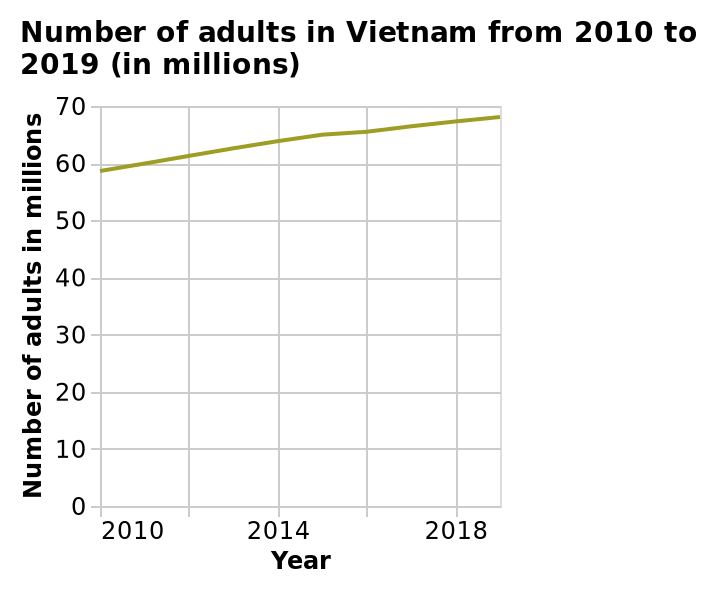<image>
What was the approximate number of Vietnamese adults in 2010?  Just under 60 million adults. What is the range of the y-axis in the line plot?  The range of the y-axis in the line plot is from 0 to 70, labeled Number of adults in millions. Describe the following image in detail Number of adults in Vietnam from 2010 to 2019 (in millions) is a line plot. Year is drawn using a linear scale from 2010 to 2018 along the x-axis. There is a linear scale from 0 to 70 on the y-axis, labeled Number of adults in millions. What was the percentage increase in the number of Vietnamese adults between 2010 and 2019? The percentage increase in the number of Vietnamese adults was approximately 16.6%. 